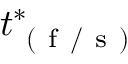Convert formula to latex. <formula><loc_0><loc_0><loc_500><loc_500>t _ { ( f / s ) } ^ { * }</formula> 